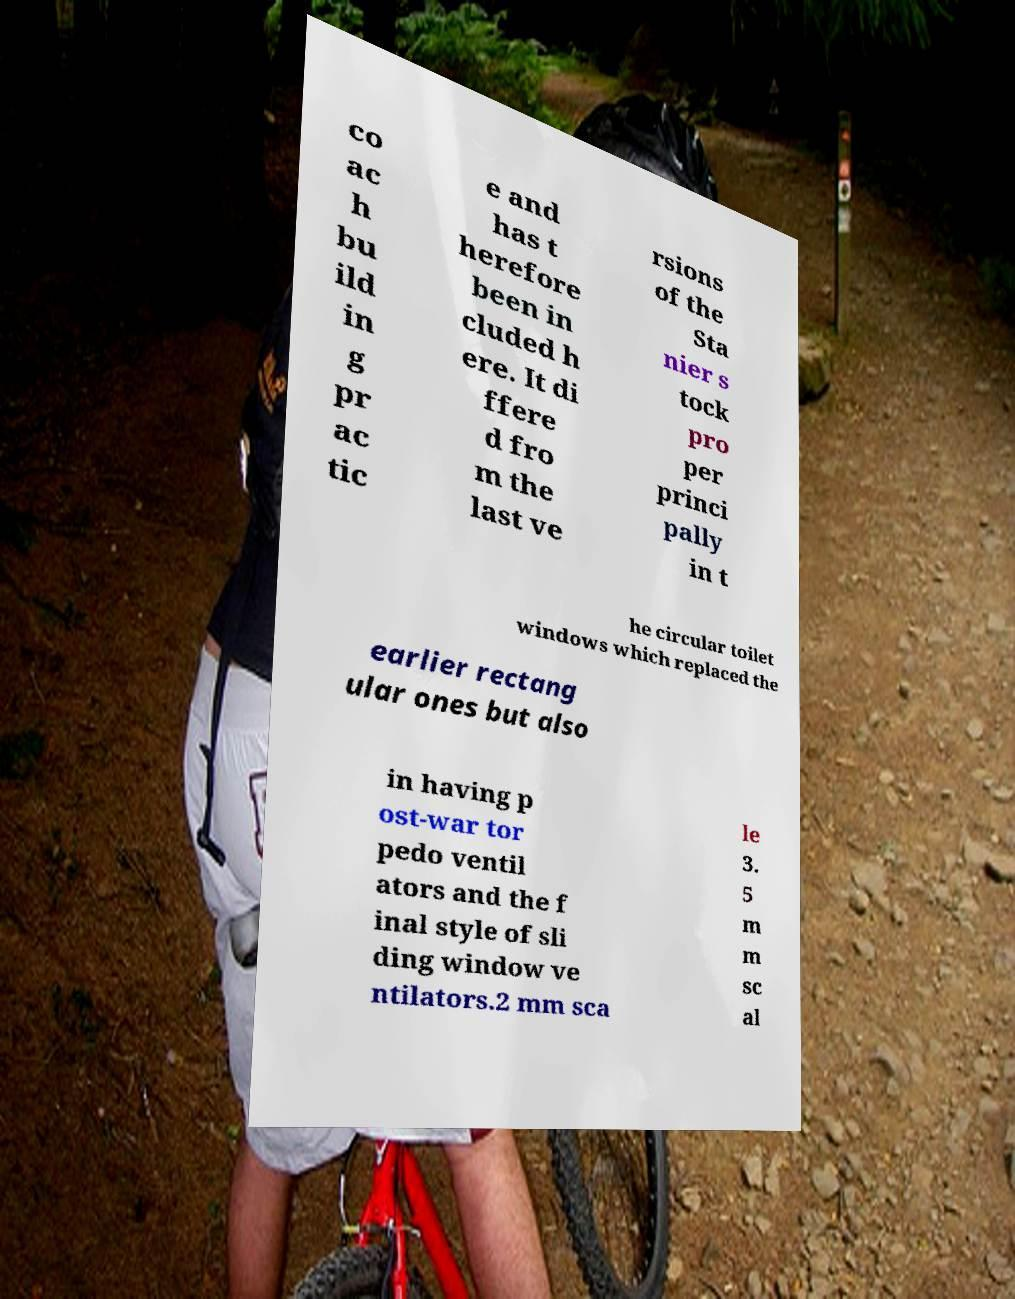I need the written content from this picture converted into text. Can you do that? co ac h bu ild in g pr ac tic e and has t herefore been in cluded h ere. It di ffere d fro m the last ve rsions of the Sta nier s tock pro per princi pally in t he circular toilet windows which replaced the earlier rectang ular ones but also in having p ost-war tor pedo ventil ators and the f inal style of sli ding window ve ntilators.2 mm sca le 3. 5 m m sc al 